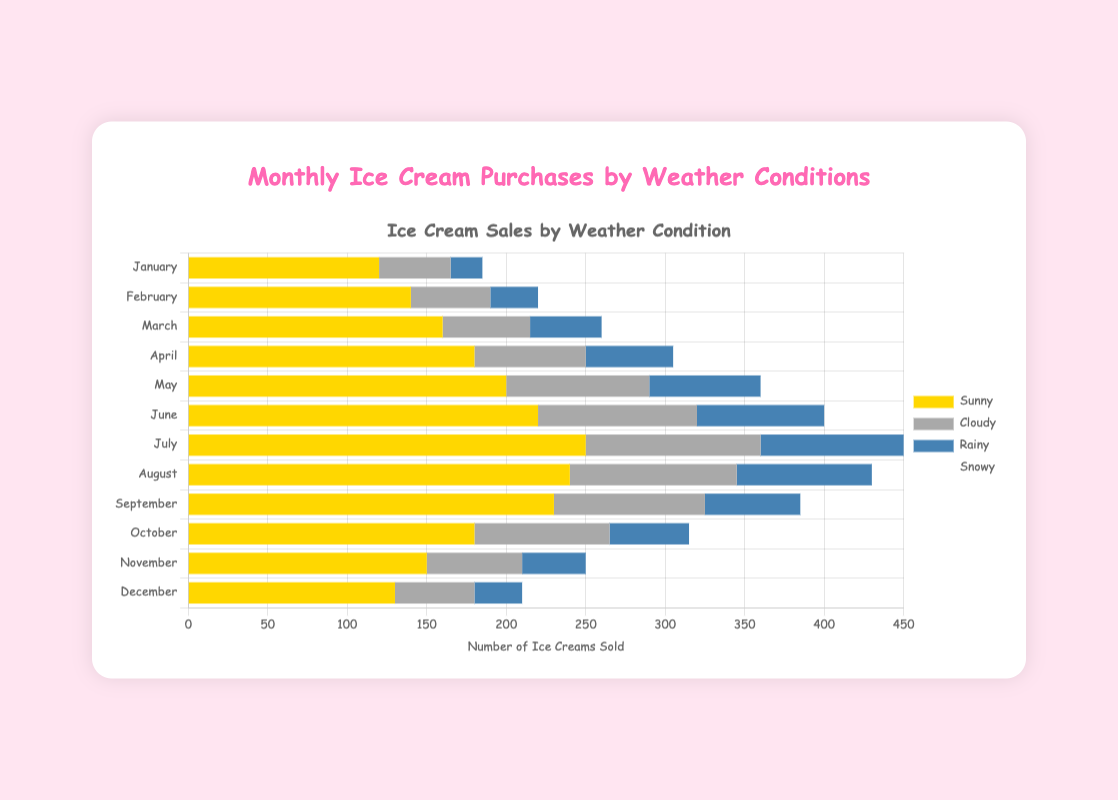What month had the highest number of ice cream purchases on sunny days? Look at the length of the 'Sunny' bars for each month and compare them. The longest bar corresponds to July.
Answer: July In which month were the ice cream purchases on snowy days equal to those on rainy days? Examine the 'Snowy' and 'Rainy' sections for each month and identify where their lengths are the same. This happens in February.
Answer: February What is the total number of ice creams sold in March on sunny and cloudy days combined? Sum the values in the 'Sunny' and 'Cloudy' categories for March. 160 (Sunny) + 55 (Cloudy) = 215.
Answer: 215 Which month had a higher number of ice cream purchases on cloudy days, June or August? Compare the lengths of the 'Cloudy' bars in June and August. June has 100, while August has 105.
Answer: August During which month of winter (December, January, February) were the total ice cream purchases the highest? Calculate the total value for December, January, and February by summing all weather categories. January is 120+45+20+5=190, February is 140+50+30+10=230, December is 130+50+30+10=220. February has the highest total at 230.
Answer: February What's the difference in the number of ice creams sold on rainy days between April and October? Subtract the 'Rainy' value for October from that of April. April has 55, October has 50, so 55 - 50 = 5.
Answer: 5 In which month were the ice cream purchases on sunny days half as much as those in July? Identify where the 'Sunny' value is roughly half of July's. July is 250, so we check for around 125. January closely matches this with 120.
Answer: January Which month saw a decrease in ice cream purchases on sunny days compared to the previous month? Compare the 'Sunny' bars sequentially. From August (240) to September (230), there's a decrease.
Answer: September How many months had fewer than 150 ice cream purchases on cloudy days? Count the months where the 'Cloudy' bar is less than 150. January, February, March, April, May, September, October, November, and December. It's 9 months.
Answer: 9 